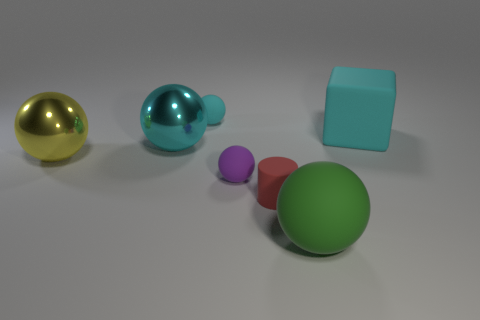Is the size of the thing behind the large cyan cube the same as the object that is in front of the tiny red cylinder?
Give a very brief answer. No. What is the object that is both behind the tiny purple rubber thing and right of the cyan rubber sphere made of?
Provide a succinct answer. Rubber. Is the number of small blue things less than the number of cyan cubes?
Provide a short and direct response. Yes. There is a cyan object that is on the left side of the small matte thing that is behind the cyan metallic sphere; what size is it?
Your answer should be compact. Large. What shape is the large shiny object behind the big metal sphere left of the big metallic object that is to the right of the large yellow metal sphere?
Your response must be concise. Sphere. What color is the block that is made of the same material as the red object?
Your answer should be compact. Cyan. There is a large sphere on the right side of the cyan ball behind the cyan ball that is on the left side of the tiny cyan matte ball; what color is it?
Give a very brief answer. Green. What number of cubes are either large green objects or cyan things?
Your answer should be compact. 1. There is a big ball that is the same color as the matte cube; what is its material?
Your response must be concise. Metal. Does the cube have the same color as the large object in front of the small red rubber object?
Provide a short and direct response. No. 